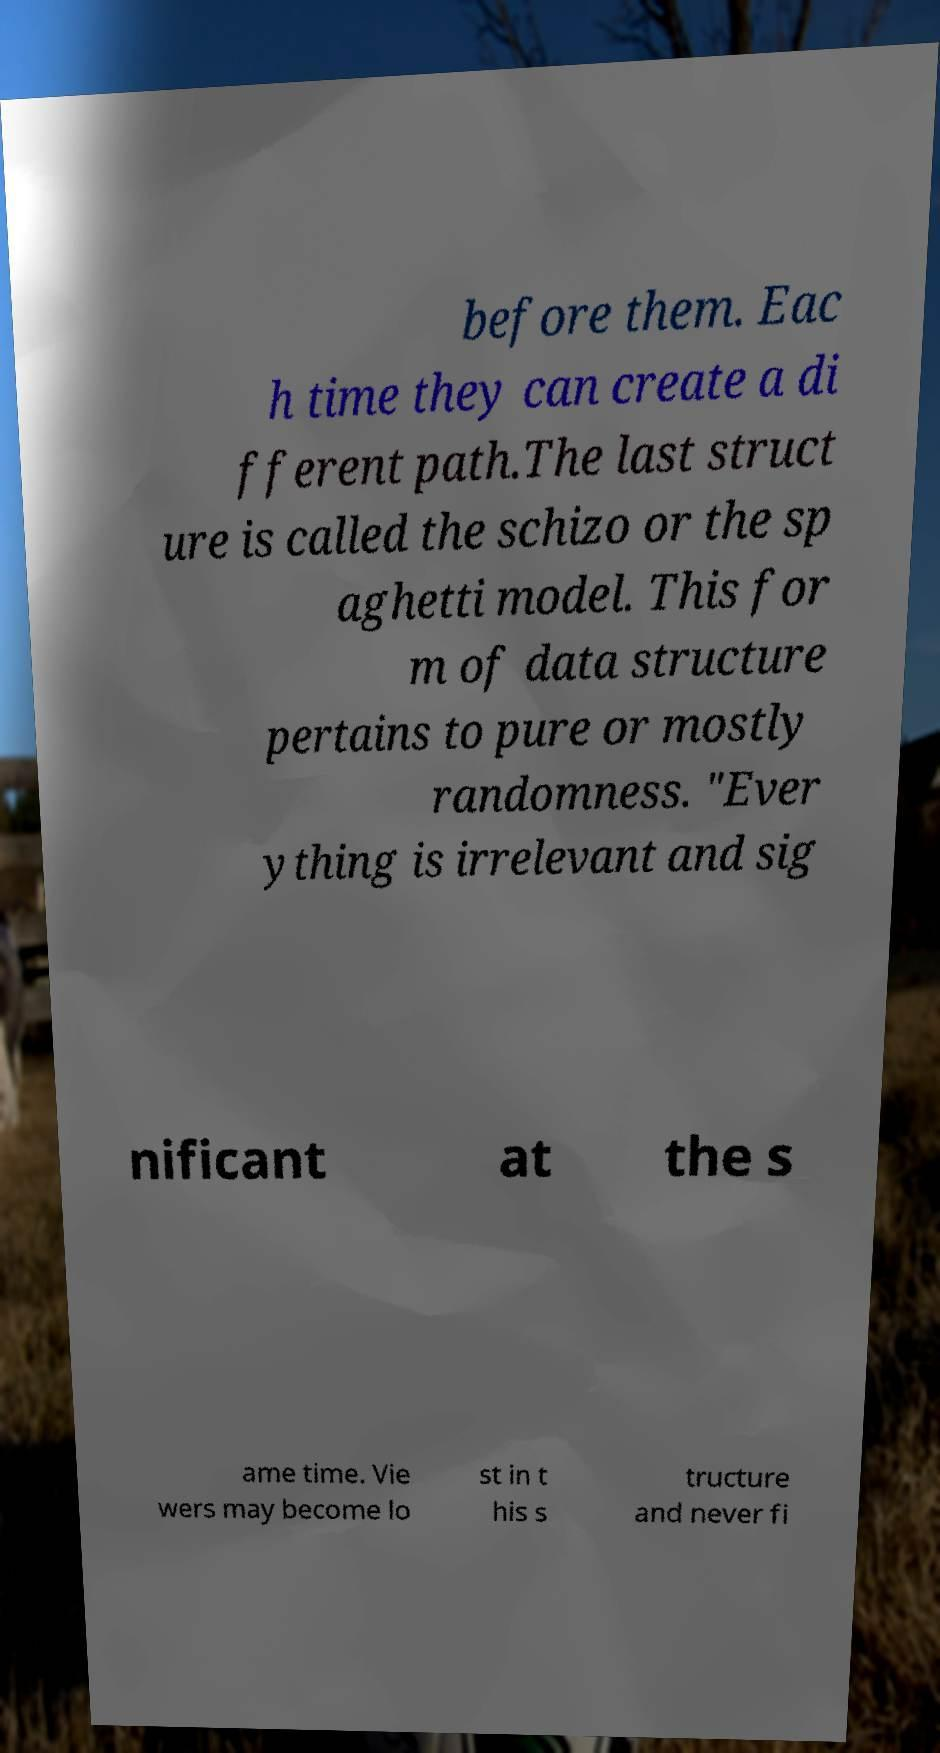Could you assist in decoding the text presented in this image and type it out clearly? before them. Eac h time they can create a di fferent path.The last struct ure is called the schizo or the sp aghetti model. This for m of data structure pertains to pure or mostly randomness. "Ever ything is irrelevant and sig nificant at the s ame time. Vie wers may become lo st in t his s tructure and never fi 